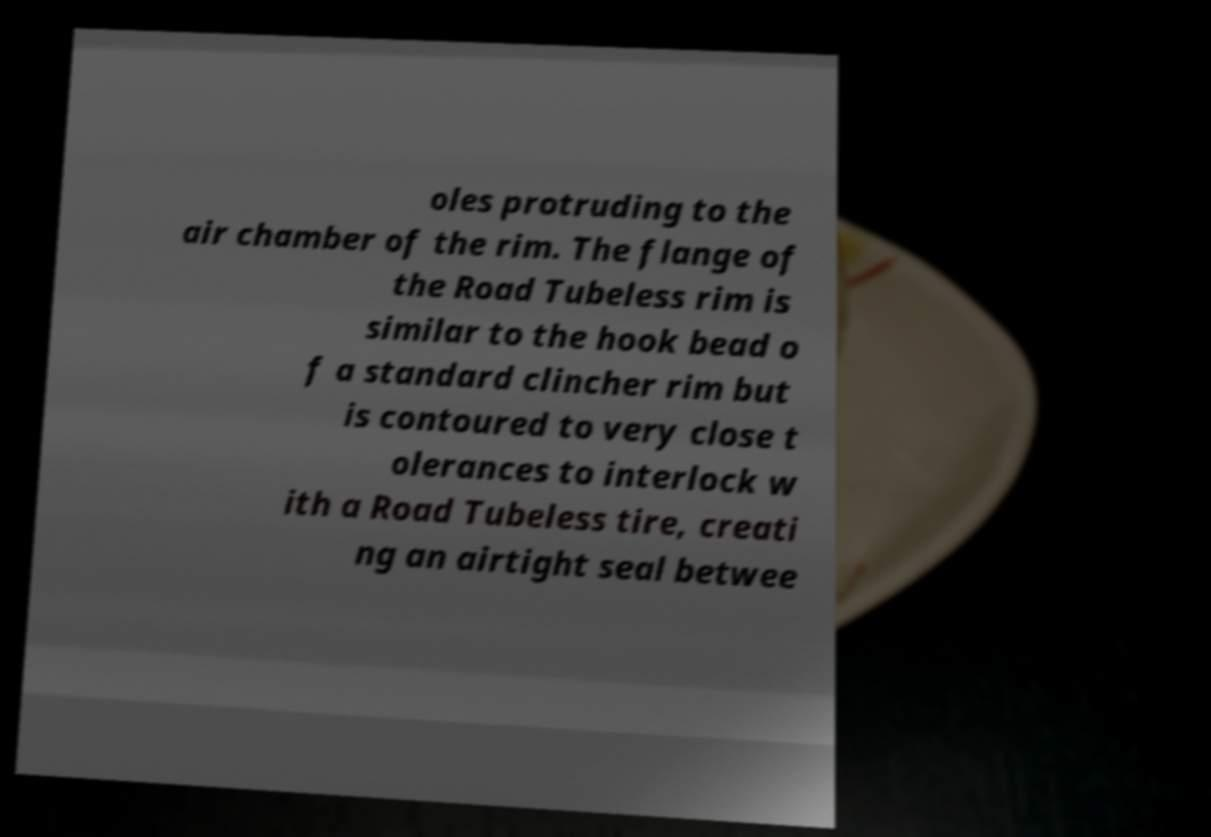For documentation purposes, I need the text within this image transcribed. Could you provide that? oles protruding to the air chamber of the rim. The flange of the Road Tubeless rim is similar to the hook bead o f a standard clincher rim but is contoured to very close t olerances to interlock w ith a Road Tubeless tire, creati ng an airtight seal betwee 